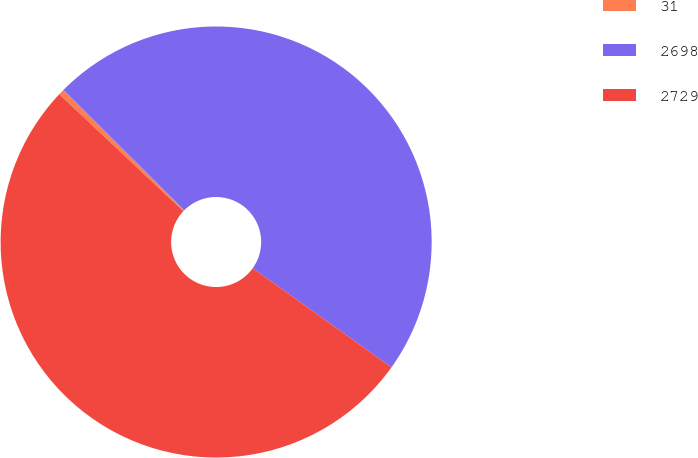Convert chart to OTSL. <chart><loc_0><loc_0><loc_500><loc_500><pie_chart><fcel>31<fcel>2698<fcel>2729<nl><fcel>0.44%<fcel>47.41%<fcel>52.15%<nl></chart> 